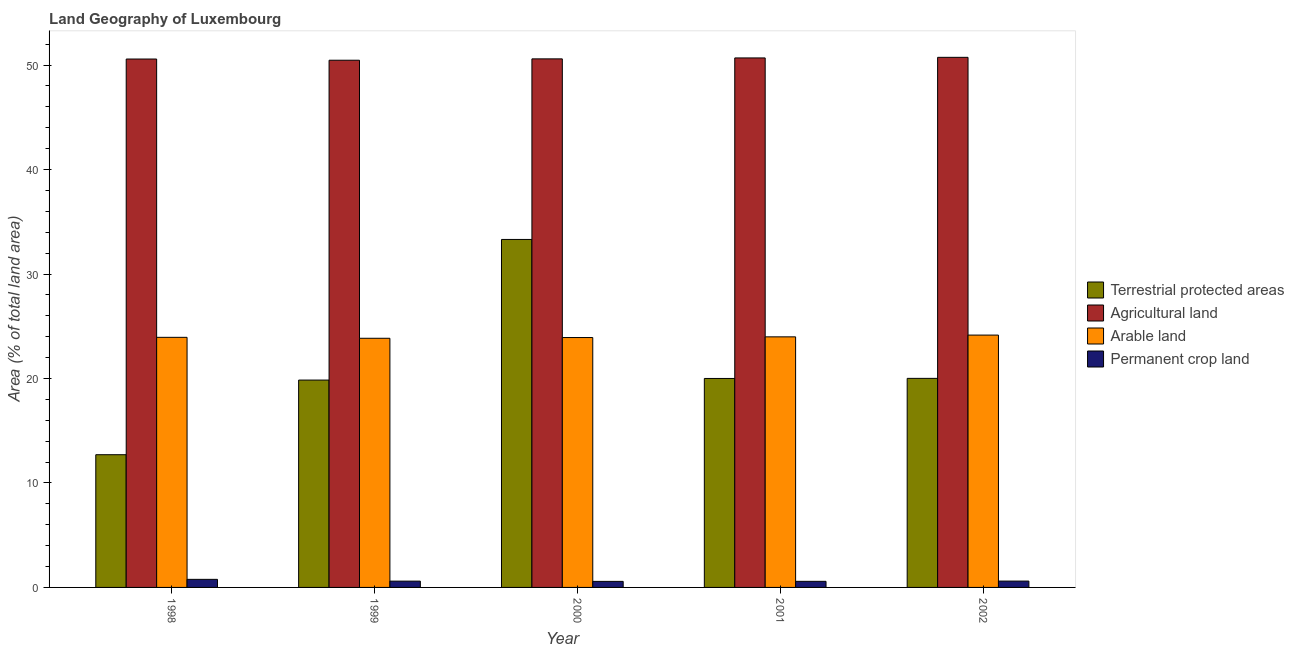How many different coloured bars are there?
Your answer should be very brief. 4. Are the number of bars per tick equal to the number of legend labels?
Keep it short and to the point. Yes. In how many cases, is the number of bars for a given year not equal to the number of legend labels?
Provide a succinct answer. 0. What is the percentage of area under arable land in 2001?
Offer a very short reply. 23.98. Across all years, what is the maximum percentage of land under terrestrial protection?
Provide a succinct answer. 33.31. Across all years, what is the minimum percentage of area under permanent crop land?
Offer a terse response. 0.58. In which year was the percentage of land under terrestrial protection maximum?
Your response must be concise. 2000. In which year was the percentage of area under permanent crop land minimum?
Offer a very short reply. 2000. What is the total percentage of land under terrestrial protection in the graph?
Offer a very short reply. 105.87. What is the difference between the percentage of area under agricultural land in 1998 and that in 2000?
Your response must be concise. -0.02. What is the difference between the percentage of area under arable land in 1999 and the percentage of land under terrestrial protection in 2000?
Ensure brevity in your answer.  -0.07. What is the average percentage of area under arable land per year?
Ensure brevity in your answer.  23.97. In the year 2001, what is the difference between the percentage of area under agricultural land and percentage of area under arable land?
Your response must be concise. 0. What is the ratio of the percentage of area under agricultural land in 2000 to that in 2002?
Your answer should be compact. 1. Is the difference between the percentage of land under terrestrial protection in 1999 and 2001 greater than the difference between the percentage of area under agricultural land in 1999 and 2001?
Give a very brief answer. No. What is the difference between the highest and the second highest percentage of area under agricultural land?
Offer a terse response. 0.06. What is the difference between the highest and the lowest percentage of area under agricultural land?
Give a very brief answer. 0.28. Is the sum of the percentage of land under terrestrial protection in 1999 and 2001 greater than the maximum percentage of area under arable land across all years?
Provide a succinct answer. Yes. What does the 3rd bar from the left in 2002 represents?
Offer a terse response. Arable land. What does the 2nd bar from the right in 1998 represents?
Provide a succinct answer. Arable land. Is it the case that in every year, the sum of the percentage of land under terrestrial protection and percentage of area under agricultural land is greater than the percentage of area under arable land?
Provide a succinct answer. Yes. How many bars are there?
Make the answer very short. 20. What is the difference between two consecutive major ticks on the Y-axis?
Your response must be concise. 10. Where does the legend appear in the graph?
Offer a very short reply. Center right. How are the legend labels stacked?
Provide a short and direct response. Vertical. What is the title of the graph?
Provide a succinct answer. Land Geography of Luxembourg. Does "Water" appear as one of the legend labels in the graph?
Your response must be concise. No. What is the label or title of the Y-axis?
Offer a very short reply. Area (% of total land area). What is the Area (% of total land area) in Terrestrial protected areas in 1998?
Your response must be concise. 12.7. What is the Area (% of total land area) in Agricultural land in 1998?
Give a very brief answer. 50.58. What is the Area (% of total land area) of Arable land in 1998?
Provide a succinct answer. 23.94. What is the Area (% of total land area) of Permanent crop land in 1998?
Make the answer very short. 0.77. What is the Area (% of total land area) in Terrestrial protected areas in 1999?
Make the answer very short. 19.85. What is the Area (% of total land area) in Agricultural land in 1999?
Offer a very short reply. 50.46. What is the Area (% of total land area) in Arable land in 1999?
Your answer should be compact. 23.85. What is the Area (% of total land area) in Permanent crop land in 1999?
Offer a very short reply. 0.6. What is the Area (% of total land area) in Terrestrial protected areas in 2000?
Your answer should be compact. 33.31. What is the Area (% of total land area) of Agricultural land in 2000?
Provide a short and direct response. 50.59. What is the Area (% of total land area) of Arable land in 2000?
Keep it short and to the point. 23.92. What is the Area (% of total land area) of Permanent crop land in 2000?
Your response must be concise. 0.58. What is the Area (% of total land area) of Terrestrial protected areas in 2001?
Give a very brief answer. 20. What is the Area (% of total land area) in Agricultural land in 2001?
Your answer should be very brief. 50.68. What is the Area (% of total land area) in Arable land in 2001?
Give a very brief answer. 23.98. What is the Area (% of total land area) of Permanent crop land in 2001?
Provide a succinct answer. 0.58. What is the Area (% of total land area) in Terrestrial protected areas in 2002?
Your response must be concise. 20.01. What is the Area (% of total land area) of Agricultural land in 2002?
Ensure brevity in your answer.  50.74. What is the Area (% of total land area) of Arable land in 2002?
Make the answer very short. 24.15. What is the Area (% of total land area) of Permanent crop land in 2002?
Your answer should be compact. 0.61. Across all years, what is the maximum Area (% of total land area) of Terrestrial protected areas?
Offer a terse response. 33.31. Across all years, what is the maximum Area (% of total land area) in Agricultural land?
Give a very brief answer. 50.74. Across all years, what is the maximum Area (% of total land area) in Arable land?
Your answer should be compact. 24.15. Across all years, what is the maximum Area (% of total land area) in Permanent crop land?
Give a very brief answer. 0.77. Across all years, what is the minimum Area (% of total land area) of Terrestrial protected areas?
Ensure brevity in your answer.  12.7. Across all years, what is the minimum Area (% of total land area) in Agricultural land?
Your response must be concise. 50.46. Across all years, what is the minimum Area (% of total land area) of Arable land?
Your response must be concise. 23.85. Across all years, what is the minimum Area (% of total land area) of Permanent crop land?
Make the answer very short. 0.58. What is the total Area (% of total land area) of Terrestrial protected areas in the graph?
Offer a terse response. 105.87. What is the total Area (% of total land area) in Agricultural land in the graph?
Give a very brief answer. 253.06. What is the total Area (% of total land area) of Arable land in the graph?
Keep it short and to the point. 119.85. What is the total Area (% of total land area) in Permanent crop land in the graph?
Your answer should be compact. 3.14. What is the difference between the Area (% of total land area) in Terrestrial protected areas in 1998 and that in 1999?
Your answer should be compact. -7.14. What is the difference between the Area (% of total land area) of Agricultural land in 1998 and that in 1999?
Give a very brief answer. 0.12. What is the difference between the Area (% of total land area) in Arable land in 1998 and that in 1999?
Offer a very short reply. 0.09. What is the difference between the Area (% of total land area) of Permanent crop land in 1998 and that in 1999?
Your response must be concise. 0.17. What is the difference between the Area (% of total land area) of Terrestrial protected areas in 1998 and that in 2000?
Offer a very short reply. -20.6. What is the difference between the Area (% of total land area) in Agricultural land in 1998 and that in 2000?
Make the answer very short. -0.02. What is the difference between the Area (% of total land area) of Arable land in 1998 and that in 2000?
Provide a succinct answer. 0.02. What is the difference between the Area (% of total land area) of Permanent crop land in 1998 and that in 2000?
Your answer should be compact. 0.19. What is the difference between the Area (% of total land area) in Terrestrial protected areas in 1998 and that in 2001?
Make the answer very short. -7.3. What is the difference between the Area (% of total land area) in Agricultural land in 1998 and that in 2001?
Offer a very short reply. -0.1. What is the difference between the Area (% of total land area) of Arable land in 1998 and that in 2001?
Offer a terse response. -0.05. What is the difference between the Area (% of total land area) of Permanent crop land in 1998 and that in 2001?
Offer a terse response. 0.19. What is the difference between the Area (% of total land area) of Terrestrial protected areas in 1998 and that in 2002?
Your response must be concise. -7.31. What is the difference between the Area (% of total land area) of Agricultural land in 1998 and that in 2002?
Your answer should be compact. -0.16. What is the difference between the Area (% of total land area) of Arable land in 1998 and that in 2002?
Your response must be concise. -0.22. What is the difference between the Area (% of total land area) of Permanent crop land in 1998 and that in 2002?
Provide a short and direct response. 0.17. What is the difference between the Area (% of total land area) of Terrestrial protected areas in 1999 and that in 2000?
Ensure brevity in your answer.  -13.46. What is the difference between the Area (% of total land area) of Agricultural land in 1999 and that in 2000?
Make the answer very short. -0.13. What is the difference between the Area (% of total land area) in Arable land in 1999 and that in 2000?
Your answer should be very brief. -0.07. What is the difference between the Area (% of total land area) in Permanent crop land in 1999 and that in 2000?
Give a very brief answer. 0.02. What is the difference between the Area (% of total land area) of Terrestrial protected areas in 1999 and that in 2001?
Your answer should be compact. -0.15. What is the difference between the Area (% of total land area) in Agricultural land in 1999 and that in 2001?
Provide a short and direct response. -0.22. What is the difference between the Area (% of total land area) of Arable land in 1999 and that in 2001?
Keep it short and to the point. -0.14. What is the difference between the Area (% of total land area) of Permanent crop land in 1999 and that in 2001?
Make the answer very short. 0.02. What is the difference between the Area (% of total land area) in Terrestrial protected areas in 1999 and that in 2002?
Give a very brief answer. -0.16. What is the difference between the Area (% of total land area) in Agricultural land in 1999 and that in 2002?
Offer a very short reply. -0.28. What is the difference between the Area (% of total land area) in Arable land in 1999 and that in 2002?
Provide a succinct answer. -0.3. What is the difference between the Area (% of total land area) in Permanent crop land in 1999 and that in 2002?
Keep it short and to the point. -0. What is the difference between the Area (% of total land area) in Terrestrial protected areas in 2000 and that in 2001?
Make the answer very short. 13.31. What is the difference between the Area (% of total land area) of Agricultural land in 2000 and that in 2001?
Make the answer very short. -0.09. What is the difference between the Area (% of total land area) in Arable land in 2000 and that in 2001?
Keep it short and to the point. -0.07. What is the difference between the Area (% of total land area) in Permanent crop land in 2000 and that in 2001?
Give a very brief answer. -0. What is the difference between the Area (% of total land area) of Terrestrial protected areas in 2000 and that in 2002?
Provide a succinct answer. 13.3. What is the difference between the Area (% of total land area) in Agricultural land in 2000 and that in 2002?
Give a very brief answer. -0.15. What is the difference between the Area (% of total land area) in Arable land in 2000 and that in 2002?
Offer a very short reply. -0.24. What is the difference between the Area (% of total land area) in Permanent crop land in 2000 and that in 2002?
Your response must be concise. -0.03. What is the difference between the Area (% of total land area) of Terrestrial protected areas in 2001 and that in 2002?
Give a very brief answer. -0.01. What is the difference between the Area (% of total land area) in Agricultural land in 2001 and that in 2002?
Your response must be concise. -0.06. What is the difference between the Area (% of total land area) of Arable land in 2001 and that in 2002?
Keep it short and to the point. -0.17. What is the difference between the Area (% of total land area) in Permanent crop land in 2001 and that in 2002?
Offer a terse response. -0.02. What is the difference between the Area (% of total land area) of Terrestrial protected areas in 1998 and the Area (% of total land area) of Agricultural land in 1999?
Offer a very short reply. -37.76. What is the difference between the Area (% of total land area) in Terrestrial protected areas in 1998 and the Area (% of total land area) in Arable land in 1999?
Provide a succinct answer. -11.15. What is the difference between the Area (% of total land area) of Terrestrial protected areas in 1998 and the Area (% of total land area) of Permanent crop land in 1999?
Provide a short and direct response. 12.1. What is the difference between the Area (% of total land area) in Agricultural land in 1998 and the Area (% of total land area) in Arable land in 1999?
Offer a terse response. 26.73. What is the difference between the Area (% of total land area) of Agricultural land in 1998 and the Area (% of total land area) of Permanent crop land in 1999?
Offer a terse response. 49.98. What is the difference between the Area (% of total land area) of Arable land in 1998 and the Area (% of total land area) of Permanent crop land in 1999?
Make the answer very short. 23.34. What is the difference between the Area (% of total land area) of Terrestrial protected areas in 1998 and the Area (% of total land area) of Agricultural land in 2000?
Provide a succinct answer. -37.89. What is the difference between the Area (% of total land area) in Terrestrial protected areas in 1998 and the Area (% of total land area) in Arable land in 2000?
Your answer should be very brief. -11.22. What is the difference between the Area (% of total land area) in Terrestrial protected areas in 1998 and the Area (% of total land area) in Permanent crop land in 2000?
Your answer should be compact. 12.12. What is the difference between the Area (% of total land area) of Agricultural land in 1998 and the Area (% of total land area) of Arable land in 2000?
Provide a short and direct response. 26.66. What is the difference between the Area (% of total land area) of Arable land in 1998 and the Area (% of total land area) of Permanent crop land in 2000?
Offer a very short reply. 23.36. What is the difference between the Area (% of total land area) of Terrestrial protected areas in 1998 and the Area (% of total land area) of Agricultural land in 2001?
Make the answer very short. -37.98. What is the difference between the Area (% of total land area) in Terrestrial protected areas in 1998 and the Area (% of total land area) in Arable land in 2001?
Offer a very short reply. -11.28. What is the difference between the Area (% of total land area) of Terrestrial protected areas in 1998 and the Area (% of total land area) of Permanent crop land in 2001?
Offer a terse response. 12.12. What is the difference between the Area (% of total land area) of Agricultural land in 1998 and the Area (% of total land area) of Arable land in 2001?
Your answer should be very brief. 26.59. What is the difference between the Area (% of total land area) in Agricultural land in 1998 and the Area (% of total land area) in Permanent crop land in 2001?
Keep it short and to the point. 50. What is the difference between the Area (% of total land area) of Arable land in 1998 and the Area (% of total land area) of Permanent crop land in 2001?
Offer a terse response. 23.36. What is the difference between the Area (% of total land area) in Terrestrial protected areas in 1998 and the Area (% of total land area) in Agricultural land in 2002?
Make the answer very short. -38.04. What is the difference between the Area (% of total land area) of Terrestrial protected areas in 1998 and the Area (% of total land area) of Arable land in 2002?
Keep it short and to the point. -11.45. What is the difference between the Area (% of total land area) of Terrestrial protected areas in 1998 and the Area (% of total land area) of Permanent crop land in 2002?
Provide a short and direct response. 12.1. What is the difference between the Area (% of total land area) of Agricultural land in 1998 and the Area (% of total land area) of Arable land in 2002?
Your response must be concise. 26.42. What is the difference between the Area (% of total land area) in Agricultural land in 1998 and the Area (% of total land area) in Permanent crop land in 2002?
Keep it short and to the point. 49.97. What is the difference between the Area (% of total land area) of Arable land in 1998 and the Area (% of total land area) of Permanent crop land in 2002?
Keep it short and to the point. 23.33. What is the difference between the Area (% of total land area) of Terrestrial protected areas in 1999 and the Area (% of total land area) of Agricultural land in 2000?
Provide a short and direct response. -30.75. What is the difference between the Area (% of total land area) in Terrestrial protected areas in 1999 and the Area (% of total land area) in Arable land in 2000?
Provide a short and direct response. -4.07. What is the difference between the Area (% of total land area) of Terrestrial protected areas in 1999 and the Area (% of total land area) of Permanent crop land in 2000?
Provide a succinct answer. 19.27. What is the difference between the Area (% of total land area) of Agricultural land in 1999 and the Area (% of total land area) of Arable land in 2000?
Your answer should be compact. 26.54. What is the difference between the Area (% of total land area) in Agricultural land in 1999 and the Area (% of total land area) in Permanent crop land in 2000?
Provide a short and direct response. 49.88. What is the difference between the Area (% of total land area) of Arable land in 1999 and the Area (% of total land area) of Permanent crop land in 2000?
Provide a succinct answer. 23.27. What is the difference between the Area (% of total land area) of Terrestrial protected areas in 1999 and the Area (% of total land area) of Agricultural land in 2001?
Provide a short and direct response. -30.84. What is the difference between the Area (% of total land area) in Terrestrial protected areas in 1999 and the Area (% of total land area) in Arable land in 2001?
Provide a succinct answer. -4.14. What is the difference between the Area (% of total land area) of Terrestrial protected areas in 1999 and the Area (% of total land area) of Permanent crop land in 2001?
Keep it short and to the point. 19.26. What is the difference between the Area (% of total land area) of Agricultural land in 1999 and the Area (% of total land area) of Arable land in 2001?
Keep it short and to the point. 26.48. What is the difference between the Area (% of total land area) of Agricultural land in 1999 and the Area (% of total land area) of Permanent crop land in 2001?
Your response must be concise. 49.88. What is the difference between the Area (% of total land area) of Arable land in 1999 and the Area (% of total land area) of Permanent crop land in 2001?
Make the answer very short. 23.27. What is the difference between the Area (% of total land area) in Terrestrial protected areas in 1999 and the Area (% of total land area) in Agricultural land in 2002?
Provide a short and direct response. -30.89. What is the difference between the Area (% of total land area) in Terrestrial protected areas in 1999 and the Area (% of total land area) in Arable land in 2002?
Your response must be concise. -4.31. What is the difference between the Area (% of total land area) of Terrestrial protected areas in 1999 and the Area (% of total land area) of Permanent crop land in 2002?
Your response must be concise. 19.24. What is the difference between the Area (% of total land area) of Agricultural land in 1999 and the Area (% of total land area) of Arable land in 2002?
Offer a very short reply. 26.31. What is the difference between the Area (% of total land area) in Agricultural land in 1999 and the Area (% of total land area) in Permanent crop land in 2002?
Ensure brevity in your answer.  49.86. What is the difference between the Area (% of total land area) of Arable land in 1999 and the Area (% of total land area) of Permanent crop land in 2002?
Keep it short and to the point. 23.24. What is the difference between the Area (% of total land area) in Terrestrial protected areas in 2000 and the Area (% of total land area) in Agricultural land in 2001?
Your answer should be very brief. -17.37. What is the difference between the Area (% of total land area) in Terrestrial protected areas in 2000 and the Area (% of total land area) in Arable land in 2001?
Provide a short and direct response. 9.32. What is the difference between the Area (% of total land area) in Terrestrial protected areas in 2000 and the Area (% of total land area) in Permanent crop land in 2001?
Provide a succinct answer. 32.73. What is the difference between the Area (% of total land area) of Agricultural land in 2000 and the Area (% of total land area) of Arable land in 2001?
Provide a short and direct response. 26.61. What is the difference between the Area (% of total land area) in Agricultural land in 2000 and the Area (% of total land area) in Permanent crop land in 2001?
Provide a succinct answer. 50.01. What is the difference between the Area (% of total land area) in Arable land in 2000 and the Area (% of total land area) in Permanent crop land in 2001?
Provide a succinct answer. 23.34. What is the difference between the Area (% of total land area) of Terrestrial protected areas in 2000 and the Area (% of total land area) of Agricultural land in 2002?
Offer a terse response. -17.43. What is the difference between the Area (% of total land area) in Terrestrial protected areas in 2000 and the Area (% of total land area) in Arable land in 2002?
Provide a short and direct response. 9.15. What is the difference between the Area (% of total land area) of Terrestrial protected areas in 2000 and the Area (% of total land area) of Permanent crop land in 2002?
Offer a terse response. 32.7. What is the difference between the Area (% of total land area) in Agricultural land in 2000 and the Area (% of total land area) in Arable land in 2002?
Your answer should be very brief. 26.44. What is the difference between the Area (% of total land area) in Agricultural land in 2000 and the Area (% of total land area) in Permanent crop land in 2002?
Your answer should be very brief. 49.99. What is the difference between the Area (% of total land area) of Arable land in 2000 and the Area (% of total land area) of Permanent crop land in 2002?
Your answer should be very brief. 23.31. What is the difference between the Area (% of total land area) of Terrestrial protected areas in 2001 and the Area (% of total land area) of Agricultural land in 2002?
Your answer should be very brief. -30.74. What is the difference between the Area (% of total land area) of Terrestrial protected areas in 2001 and the Area (% of total land area) of Arable land in 2002?
Give a very brief answer. -4.15. What is the difference between the Area (% of total land area) of Terrestrial protected areas in 2001 and the Area (% of total land area) of Permanent crop land in 2002?
Provide a succinct answer. 19.4. What is the difference between the Area (% of total land area) of Agricultural land in 2001 and the Area (% of total land area) of Arable land in 2002?
Ensure brevity in your answer.  26.53. What is the difference between the Area (% of total land area) of Agricultural land in 2001 and the Area (% of total land area) of Permanent crop land in 2002?
Provide a short and direct response. 50.08. What is the difference between the Area (% of total land area) of Arable land in 2001 and the Area (% of total land area) of Permanent crop land in 2002?
Offer a very short reply. 23.38. What is the average Area (% of total land area) in Terrestrial protected areas per year?
Keep it short and to the point. 21.17. What is the average Area (% of total land area) of Agricultural land per year?
Offer a terse response. 50.61. What is the average Area (% of total land area) of Arable land per year?
Keep it short and to the point. 23.97. What is the average Area (% of total land area) in Permanent crop land per year?
Your response must be concise. 0.63. In the year 1998, what is the difference between the Area (% of total land area) of Terrestrial protected areas and Area (% of total land area) of Agricultural land?
Make the answer very short. -37.88. In the year 1998, what is the difference between the Area (% of total land area) of Terrestrial protected areas and Area (% of total land area) of Arable land?
Ensure brevity in your answer.  -11.23. In the year 1998, what is the difference between the Area (% of total land area) in Terrestrial protected areas and Area (% of total land area) in Permanent crop land?
Make the answer very short. 11.93. In the year 1998, what is the difference between the Area (% of total land area) in Agricultural land and Area (% of total land area) in Arable land?
Your response must be concise. 26.64. In the year 1998, what is the difference between the Area (% of total land area) of Agricultural land and Area (% of total land area) of Permanent crop land?
Your answer should be very brief. 49.81. In the year 1998, what is the difference between the Area (% of total land area) of Arable land and Area (% of total land area) of Permanent crop land?
Provide a short and direct response. 23.17. In the year 1999, what is the difference between the Area (% of total land area) of Terrestrial protected areas and Area (% of total land area) of Agricultural land?
Your answer should be compact. -30.62. In the year 1999, what is the difference between the Area (% of total land area) in Terrestrial protected areas and Area (% of total land area) in Arable land?
Keep it short and to the point. -4. In the year 1999, what is the difference between the Area (% of total land area) in Terrestrial protected areas and Area (% of total land area) in Permanent crop land?
Provide a short and direct response. 19.25. In the year 1999, what is the difference between the Area (% of total land area) in Agricultural land and Area (% of total land area) in Arable land?
Offer a very short reply. 26.61. In the year 1999, what is the difference between the Area (% of total land area) of Agricultural land and Area (% of total land area) of Permanent crop land?
Keep it short and to the point. 49.86. In the year 1999, what is the difference between the Area (% of total land area) in Arable land and Area (% of total land area) in Permanent crop land?
Offer a terse response. 23.25. In the year 2000, what is the difference between the Area (% of total land area) in Terrestrial protected areas and Area (% of total land area) in Agricultural land?
Your response must be concise. -17.29. In the year 2000, what is the difference between the Area (% of total land area) of Terrestrial protected areas and Area (% of total land area) of Arable land?
Offer a terse response. 9.39. In the year 2000, what is the difference between the Area (% of total land area) in Terrestrial protected areas and Area (% of total land area) in Permanent crop land?
Your answer should be compact. 32.73. In the year 2000, what is the difference between the Area (% of total land area) in Agricultural land and Area (% of total land area) in Arable land?
Your answer should be compact. 26.68. In the year 2000, what is the difference between the Area (% of total land area) of Agricultural land and Area (% of total land area) of Permanent crop land?
Your response must be concise. 50.02. In the year 2000, what is the difference between the Area (% of total land area) of Arable land and Area (% of total land area) of Permanent crop land?
Your response must be concise. 23.34. In the year 2001, what is the difference between the Area (% of total land area) in Terrestrial protected areas and Area (% of total land area) in Agricultural land?
Make the answer very short. -30.68. In the year 2001, what is the difference between the Area (% of total land area) in Terrestrial protected areas and Area (% of total land area) in Arable land?
Ensure brevity in your answer.  -3.98. In the year 2001, what is the difference between the Area (% of total land area) of Terrestrial protected areas and Area (% of total land area) of Permanent crop land?
Your response must be concise. 19.42. In the year 2001, what is the difference between the Area (% of total land area) of Agricultural land and Area (% of total land area) of Arable land?
Your answer should be compact. 26.7. In the year 2001, what is the difference between the Area (% of total land area) in Agricultural land and Area (% of total land area) in Permanent crop land?
Provide a succinct answer. 50.1. In the year 2001, what is the difference between the Area (% of total land area) of Arable land and Area (% of total land area) of Permanent crop land?
Offer a very short reply. 23.4. In the year 2002, what is the difference between the Area (% of total land area) of Terrestrial protected areas and Area (% of total land area) of Agricultural land?
Provide a succinct answer. -30.73. In the year 2002, what is the difference between the Area (% of total land area) of Terrestrial protected areas and Area (% of total land area) of Arable land?
Keep it short and to the point. -4.14. In the year 2002, what is the difference between the Area (% of total land area) in Terrestrial protected areas and Area (% of total land area) in Permanent crop land?
Provide a succinct answer. 19.41. In the year 2002, what is the difference between the Area (% of total land area) in Agricultural land and Area (% of total land area) in Arable land?
Offer a terse response. 26.59. In the year 2002, what is the difference between the Area (% of total land area) of Agricultural land and Area (% of total land area) of Permanent crop land?
Make the answer very short. 50.14. In the year 2002, what is the difference between the Area (% of total land area) of Arable land and Area (% of total land area) of Permanent crop land?
Give a very brief answer. 23.55. What is the ratio of the Area (% of total land area) of Terrestrial protected areas in 1998 to that in 1999?
Your answer should be very brief. 0.64. What is the ratio of the Area (% of total land area) of Agricultural land in 1998 to that in 1999?
Your answer should be compact. 1. What is the ratio of the Area (% of total land area) of Permanent crop land in 1998 to that in 1999?
Provide a short and direct response. 1.28. What is the ratio of the Area (% of total land area) of Terrestrial protected areas in 1998 to that in 2000?
Offer a very short reply. 0.38. What is the ratio of the Area (% of total land area) of Agricultural land in 1998 to that in 2000?
Ensure brevity in your answer.  1. What is the ratio of the Area (% of total land area) of Terrestrial protected areas in 1998 to that in 2001?
Give a very brief answer. 0.64. What is the ratio of the Area (% of total land area) of Agricultural land in 1998 to that in 2001?
Offer a very short reply. 1. What is the ratio of the Area (% of total land area) in Arable land in 1998 to that in 2001?
Ensure brevity in your answer.  1. What is the ratio of the Area (% of total land area) of Permanent crop land in 1998 to that in 2001?
Your answer should be compact. 1.32. What is the ratio of the Area (% of total land area) of Terrestrial protected areas in 1998 to that in 2002?
Offer a very short reply. 0.63. What is the ratio of the Area (% of total land area) in Arable land in 1998 to that in 2002?
Provide a succinct answer. 0.99. What is the ratio of the Area (% of total land area) in Permanent crop land in 1998 to that in 2002?
Provide a short and direct response. 1.27. What is the ratio of the Area (% of total land area) in Terrestrial protected areas in 1999 to that in 2000?
Keep it short and to the point. 0.6. What is the ratio of the Area (% of total land area) in Agricultural land in 1999 to that in 2000?
Provide a short and direct response. 1. What is the ratio of the Area (% of total land area) of Agricultural land in 1999 to that in 2001?
Offer a very short reply. 1. What is the ratio of the Area (% of total land area) of Permanent crop land in 1999 to that in 2001?
Offer a terse response. 1.03. What is the ratio of the Area (% of total land area) of Agricultural land in 1999 to that in 2002?
Provide a succinct answer. 0.99. What is the ratio of the Area (% of total land area) in Arable land in 1999 to that in 2002?
Provide a succinct answer. 0.99. What is the ratio of the Area (% of total land area) of Permanent crop land in 1999 to that in 2002?
Your answer should be very brief. 0.99. What is the ratio of the Area (% of total land area) of Terrestrial protected areas in 2000 to that in 2001?
Offer a terse response. 1.67. What is the ratio of the Area (% of total land area) of Arable land in 2000 to that in 2001?
Your response must be concise. 1. What is the ratio of the Area (% of total land area) of Permanent crop land in 2000 to that in 2001?
Ensure brevity in your answer.  0.99. What is the ratio of the Area (% of total land area) in Terrestrial protected areas in 2000 to that in 2002?
Make the answer very short. 1.66. What is the ratio of the Area (% of total land area) in Arable land in 2000 to that in 2002?
Offer a very short reply. 0.99. What is the ratio of the Area (% of total land area) in Permanent crop land in 2000 to that in 2002?
Provide a short and direct response. 0.96. What is the ratio of the Area (% of total land area) of Arable land in 2001 to that in 2002?
Your answer should be very brief. 0.99. What is the ratio of the Area (% of total land area) in Permanent crop land in 2001 to that in 2002?
Ensure brevity in your answer.  0.96. What is the difference between the highest and the second highest Area (% of total land area) in Terrestrial protected areas?
Make the answer very short. 13.3. What is the difference between the highest and the second highest Area (% of total land area) of Agricultural land?
Give a very brief answer. 0.06. What is the difference between the highest and the second highest Area (% of total land area) of Arable land?
Keep it short and to the point. 0.17. What is the difference between the highest and the second highest Area (% of total land area) of Permanent crop land?
Your answer should be very brief. 0.17. What is the difference between the highest and the lowest Area (% of total land area) of Terrestrial protected areas?
Your response must be concise. 20.6. What is the difference between the highest and the lowest Area (% of total land area) in Agricultural land?
Offer a very short reply. 0.28. What is the difference between the highest and the lowest Area (% of total land area) of Arable land?
Keep it short and to the point. 0.3. What is the difference between the highest and the lowest Area (% of total land area) in Permanent crop land?
Give a very brief answer. 0.19. 